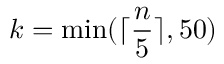<formula> <loc_0><loc_0><loc_500><loc_500>k = \min ( \lceil \frac { n } { 5 } \rceil , 5 0 )</formula> 